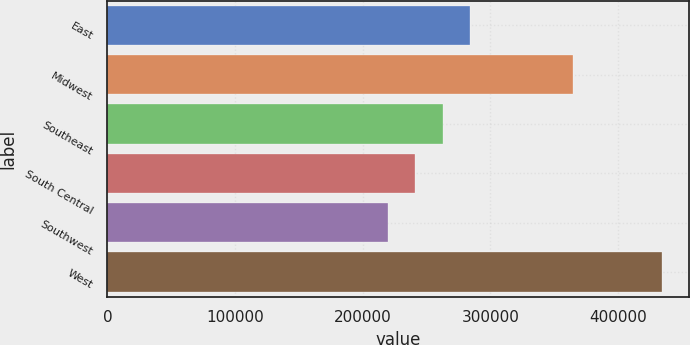Convert chart to OTSL. <chart><loc_0><loc_0><loc_500><loc_500><bar_chart><fcel>East<fcel>Midwest<fcel>Southeast<fcel>South Central<fcel>Southwest<fcel>West<nl><fcel>284050<fcel>364400<fcel>262600<fcel>241150<fcel>219700<fcel>434200<nl></chart> 